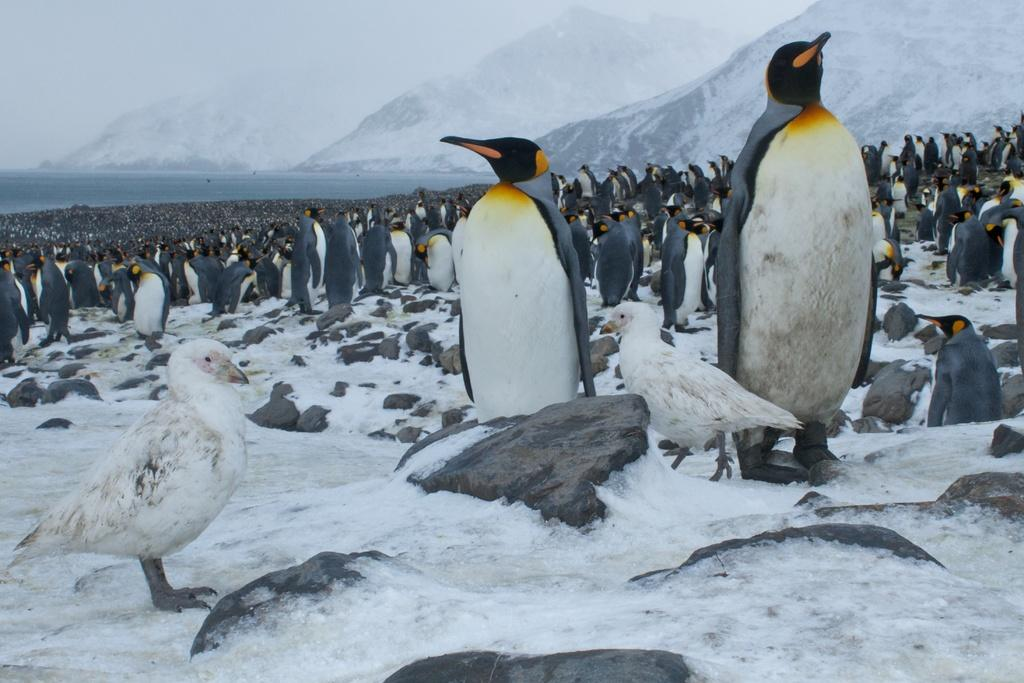What type of animals are standing in the image? There are black and white color penguins standing in the image. What other birds can be seen in the image? There are two white color birds on the ground in the image. What can be seen in the distance behind the animals? There are mountains visible in the background of the image. Where are the shoes placed in the image? There are no shoes present in the image. 